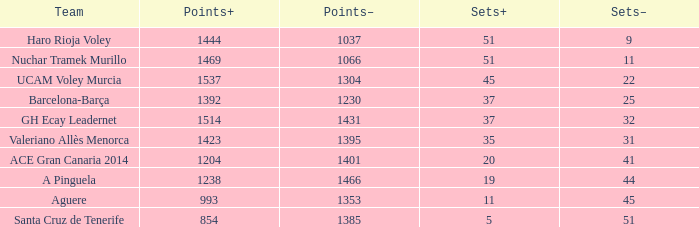What is the total number of Points- when the Sets- is larger than 51? 0.0. 